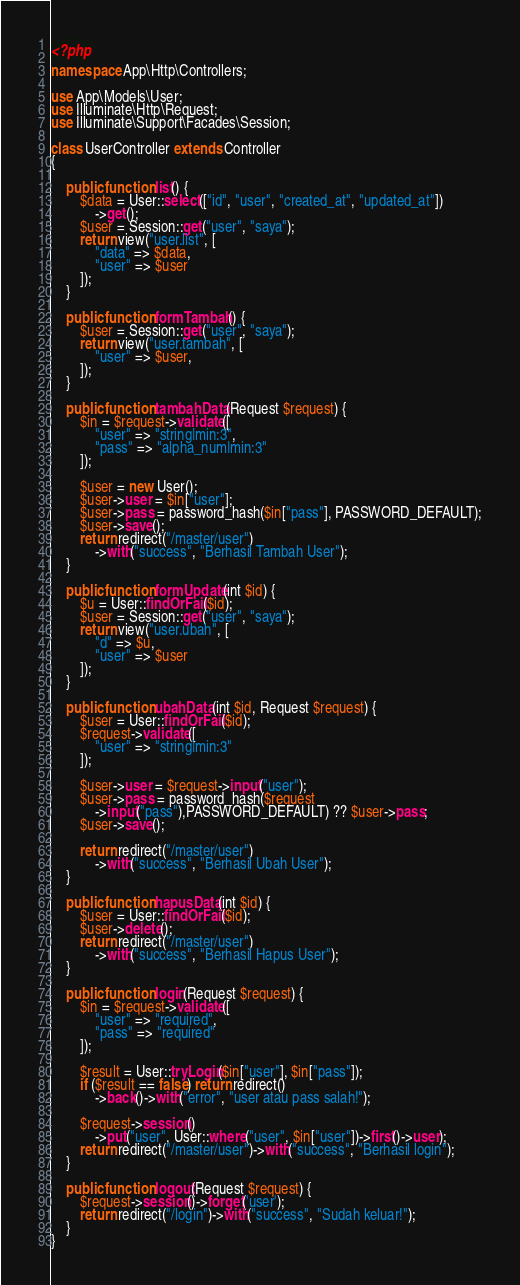Convert code to text. <code><loc_0><loc_0><loc_500><loc_500><_PHP_><?php

namespace App\Http\Controllers;

use App\Models\User;
use Illuminate\Http\Request;
use Illuminate\Support\Facades\Session;

class UserController extends Controller
{

    public function list() {
        $data = User::select(["id", "user", "created_at", "updated_at"])
            ->get();
        $user = Session::get("user", "saya");
        return view("user.list", [
            "data" => $data,
            "user" => $user
        ]);
    }

    public function formTambah() {
        $user = Session::get("user", "saya");
        return view("user.tambah", [
            "user" => $user,
        ]);
    }

    public function tambahData(Request $request) {
        $in = $request->validate([
            "user" => "string|min:3",
            "pass" => "alpha_num|min:3"
        ]);

        $user = new User();
        $user->user = $in["user"];
        $user->pass = password_hash($in["pass"], PASSWORD_DEFAULT);
        $user->save();
        return redirect("/master/user")
            ->with("success", "Berhasil Tambah User");
    }

    public function formUpdate(int $id) {
        $u = User::findOrFail($id);
        $user = Session::get("user", "saya");
        return view("user.ubah", [
            "d" => $u,
            "user" => $user
        ]);
    }

    public function ubahData(int $id, Request $request) {
        $user = User::findOrFail($id);
        $request->validate([
            "user" => "string|min:3"
        ]);

        $user->user = $request->input("user");
        $user->pass = password_hash($request
            ->input("pass"),PASSWORD_DEFAULT) ?? $user->pass;
        $user->save();

        return redirect("/master/user")
            ->with("success", "Berhasil Ubah User");
    }

    public function hapusData(int $id) {
        $user = User::findOrFail($id);
        $user->delete();
        return redirect("/master/user")
            ->with("success", "Berhasil Hapus User");
    }

    public function login(Request $request) {
        $in = $request->validate([
            "user" => "required",
            "pass" => "required"
        ]);

        $result = User::tryLogin($in["user"], $in["pass"]);
        if ($result == false) return redirect()
            ->back()->with("error", "user atau pass salah!");

        $request->session()
            ->put("user", User::where("user", $in["user"])->first()->user);
        return redirect("/master/user")->with("success", "Berhasil login");
    }

    public function logout(Request $request) {
        $request->session()->forget('user');
        return redirect("/login")->with("success", "Sudah keluar!");
    }
}
</code> 